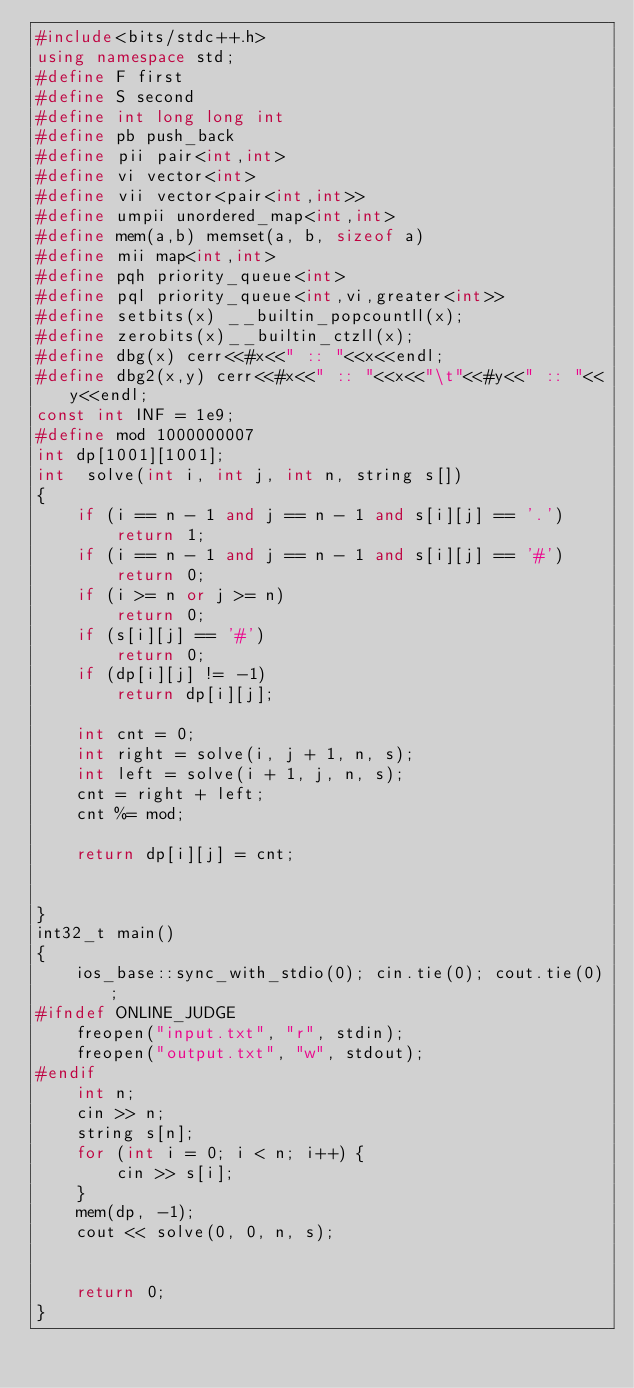<code> <loc_0><loc_0><loc_500><loc_500><_C++_>#include<bits/stdc++.h>
using namespace std;
#define F first
#define S second
#define int long long int
#define pb push_back
#define pii pair<int,int>
#define vi vector<int>
#define vii vector<pair<int,int>>
#define umpii unordered_map<int,int>
#define mem(a,b) memset(a, b, sizeof a)
#define mii map<int,int>
#define pqh priority_queue<int>
#define pql priority_queue<int,vi,greater<int>>
#define setbits(x) __builtin_popcountll(x);
#define zerobits(x)__builtin_ctzll(x);
#define dbg(x) cerr<<#x<<" :: "<<x<<endl;
#define dbg2(x,y) cerr<<#x<<" :: "<<x<<"\t"<<#y<<" :: "<<y<<endl;
const int INF = 1e9;
#define mod 1000000007
int dp[1001][1001];
int  solve(int i, int j, int n, string s[])
{
	if (i == n - 1 and j == n - 1 and s[i][j] == '.')
		return 1;
	if (i == n - 1 and j == n - 1 and s[i][j] == '#')
		return 0;
	if (i >= n or j >= n)
		return 0;
	if (s[i][j] == '#')
		return 0;
	if (dp[i][j] != -1)
		return dp[i][j];
 
	int cnt = 0;
	int right = solve(i, j + 1, n, s);
	int left = solve(i + 1, j, n, s);
	cnt = right + left;
	cnt %= mod;
 
	return dp[i][j] = cnt;
 
 
}
int32_t main()
{
	ios_base::sync_with_stdio(0); cin.tie(0); cout.tie(0);
#ifndef ONLINE_JUDGE
	freopen("input.txt", "r", stdin);
	freopen("output.txt", "w", stdout);
#endif
	int n;
	cin >> n;
	string s[n];
	for (int i = 0; i < n; i++) {
		cin >> s[i];
	}
	mem(dp, -1);
	cout << solve(0, 0, n, s);
 
 
	return 0;
}</code> 